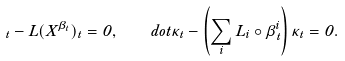Convert formula to latex. <formula><loc_0><loc_0><loc_500><loc_500>\dot { \Phi } _ { t } - L ( X ^ { \beta _ { t } } ) \Phi _ { t } = 0 , \ \ \ d o t { \kappa } _ { t } - \left ( \sum _ { i } L _ { i } \circ \beta ^ { i } _ { t } \right ) \kappa _ { t } = 0 .</formula> 